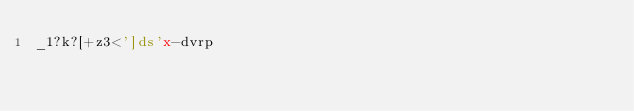Convert code to text. <code><loc_0><loc_0><loc_500><loc_500><_dc_>_1?k?[+z3<']ds'x-dvrp</code> 